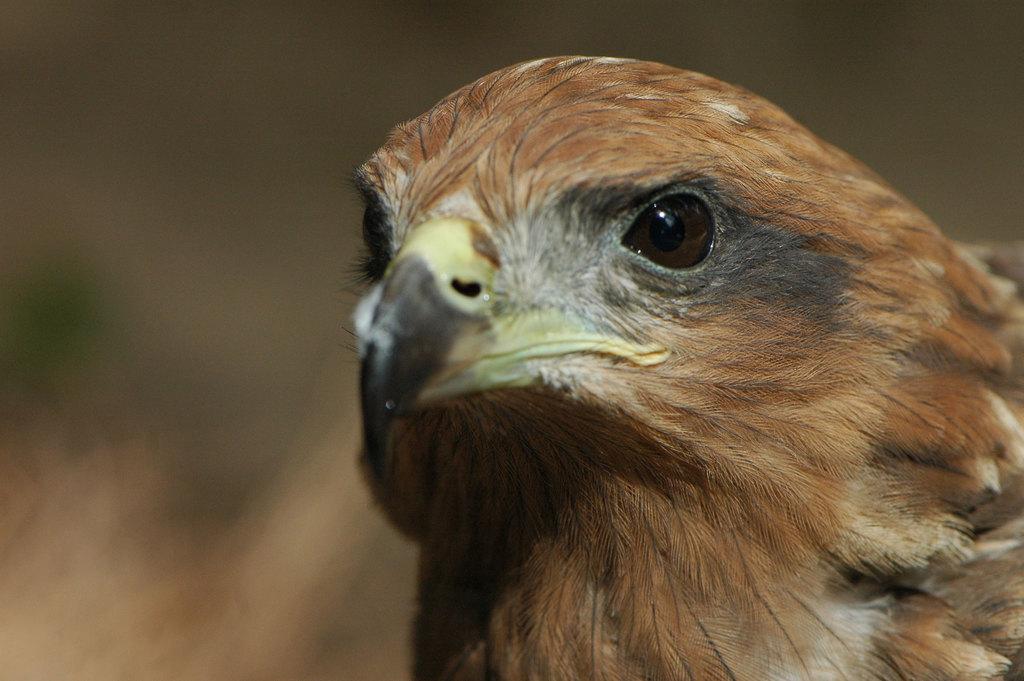How would you summarize this image in a sentence or two? In this image we can see a bird, and the background is blurred. 